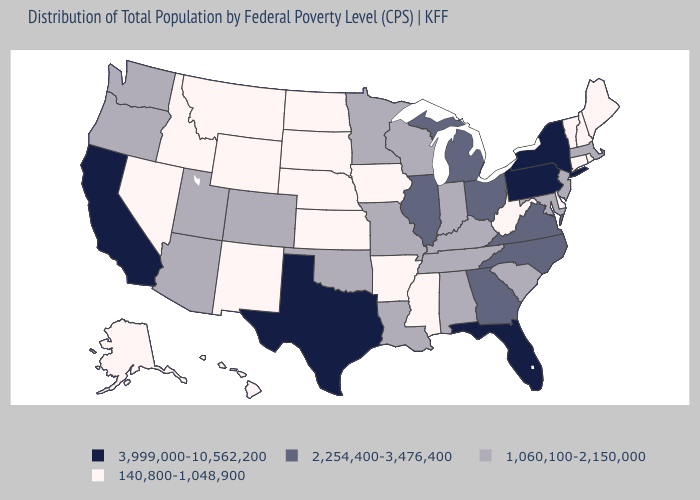Which states have the highest value in the USA?
Keep it brief. California, Florida, New York, Pennsylvania, Texas. Does Florida have the highest value in the USA?
Give a very brief answer. Yes. How many symbols are there in the legend?
Short answer required. 4. Name the states that have a value in the range 140,800-1,048,900?
Answer briefly. Alaska, Arkansas, Connecticut, Delaware, Hawaii, Idaho, Iowa, Kansas, Maine, Mississippi, Montana, Nebraska, Nevada, New Hampshire, New Mexico, North Dakota, Rhode Island, South Dakota, Vermont, West Virginia, Wyoming. Does Ohio have the lowest value in the MidWest?
Give a very brief answer. No. Name the states that have a value in the range 3,999,000-10,562,200?
Answer briefly. California, Florida, New York, Pennsylvania, Texas. Name the states that have a value in the range 3,999,000-10,562,200?
Quick response, please. California, Florida, New York, Pennsylvania, Texas. Which states hav the highest value in the West?
Write a very short answer. California. Name the states that have a value in the range 2,254,400-3,476,400?
Be succinct. Georgia, Illinois, Michigan, North Carolina, Ohio, Virginia. What is the value of Oklahoma?
Write a very short answer. 1,060,100-2,150,000. Name the states that have a value in the range 1,060,100-2,150,000?
Be succinct. Alabama, Arizona, Colorado, Indiana, Kentucky, Louisiana, Maryland, Massachusetts, Minnesota, Missouri, New Jersey, Oklahoma, Oregon, South Carolina, Tennessee, Utah, Washington, Wisconsin. What is the lowest value in the USA?
Write a very short answer. 140,800-1,048,900. Does New York have the highest value in the USA?
Keep it brief. Yes. Does Kentucky have the same value as North Carolina?
Give a very brief answer. No. Which states have the lowest value in the South?
Short answer required. Arkansas, Delaware, Mississippi, West Virginia. 